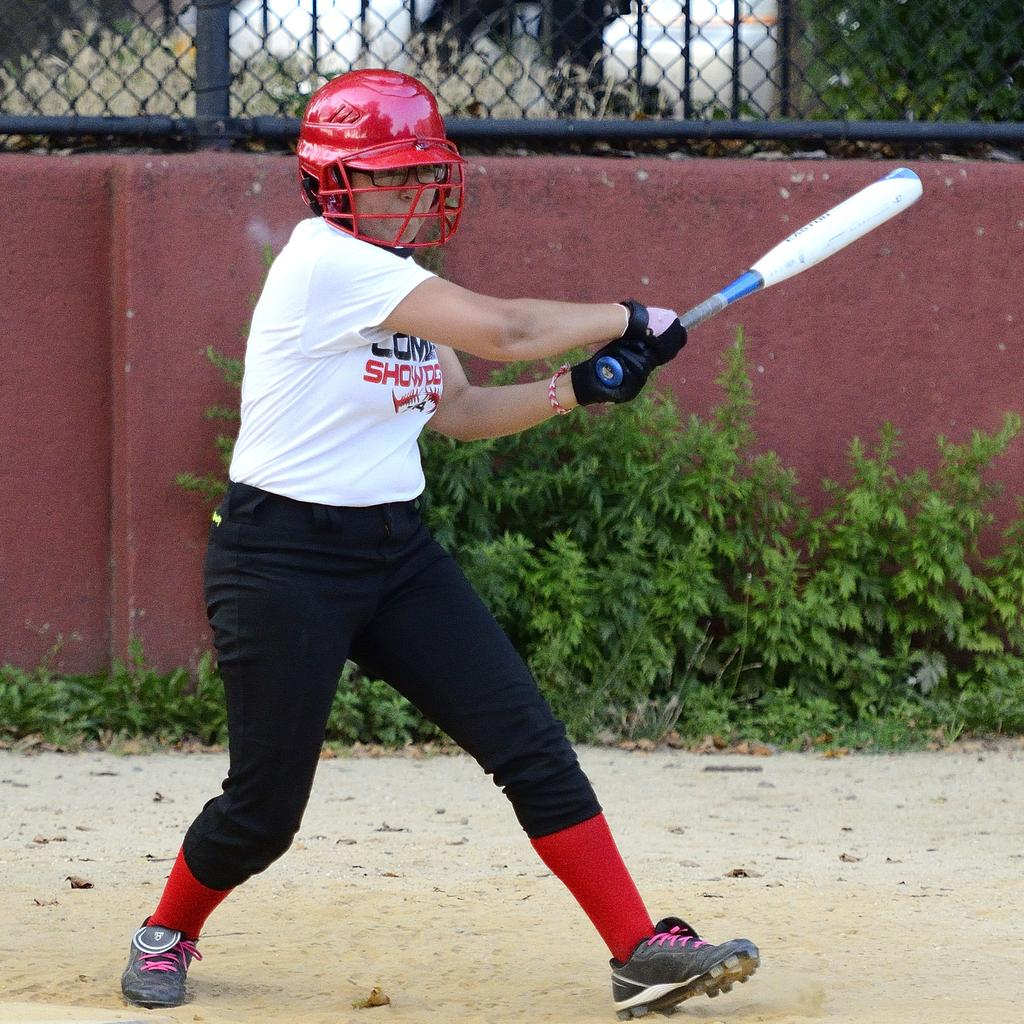What is the person in the image wearing? The person is wearing a white t-shirt and black pants. What object is the person holding in the image? The person is holding a baseball bat. What other object is visible in the image? There is a ball in the image. What is above the ball in the image? There is a fence above the ball. What is below the ball in the image? There are plants below the ball on the land. What type of account is the person opening in the image? There is no indication of an account being opened in the image. What stage of development is the pot in the image? There is no pot present in the image. 